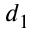<formula> <loc_0><loc_0><loc_500><loc_500>d _ { 1 }</formula> 